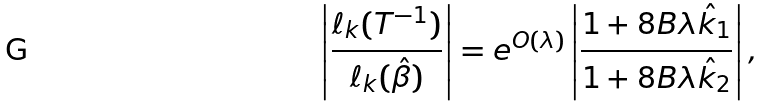<formula> <loc_0><loc_0><loc_500><loc_500>\left | \frac { \ell _ { k } ( T ^ { - 1 } ) } { \ell _ { k } ( \hat { \beta } ) } \right | = e ^ { O ( \lambda ) } \left | \frac { 1 + 8 B \lambda \hat { k } _ { 1 } } { 1 + 8 B \lambda \hat { k } _ { 2 } } \right | ,</formula> 